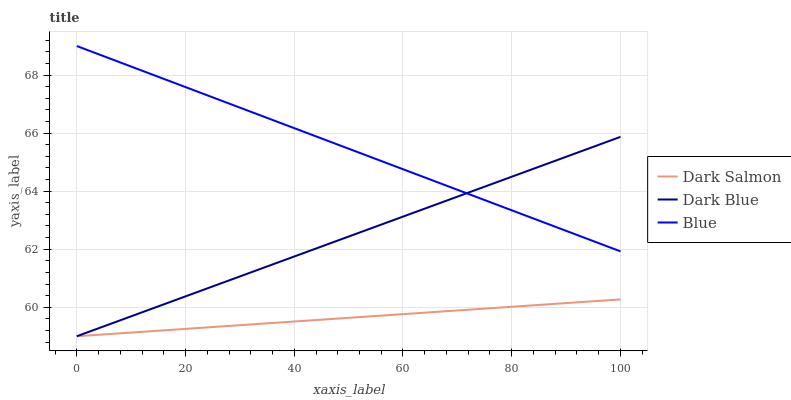Does Dark Salmon have the minimum area under the curve?
Answer yes or no. Yes. Does Blue have the maximum area under the curve?
Answer yes or no. Yes. Does Dark Blue have the minimum area under the curve?
Answer yes or no. No. Does Dark Blue have the maximum area under the curve?
Answer yes or no. No. Is Dark Blue the smoothest?
Answer yes or no. Yes. Is Blue the roughest?
Answer yes or no. Yes. Is Dark Salmon the smoothest?
Answer yes or no. No. Is Dark Salmon the roughest?
Answer yes or no. No. Does Dark Blue have the lowest value?
Answer yes or no. Yes. Does Blue have the highest value?
Answer yes or no. Yes. Does Dark Blue have the highest value?
Answer yes or no. No. Is Dark Salmon less than Blue?
Answer yes or no. Yes. Is Blue greater than Dark Salmon?
Answer yes or no. Yes. Does Blue intersect Dark Blue?
Answer yes or no. Yes. Is Blue less than Dark Blue?
Answer yes or no. No. Is Blue greater than Dark Blue?
Answer yes or no. No. Does Dark Salmon intersect Blue?
Answer yes or no. No. 